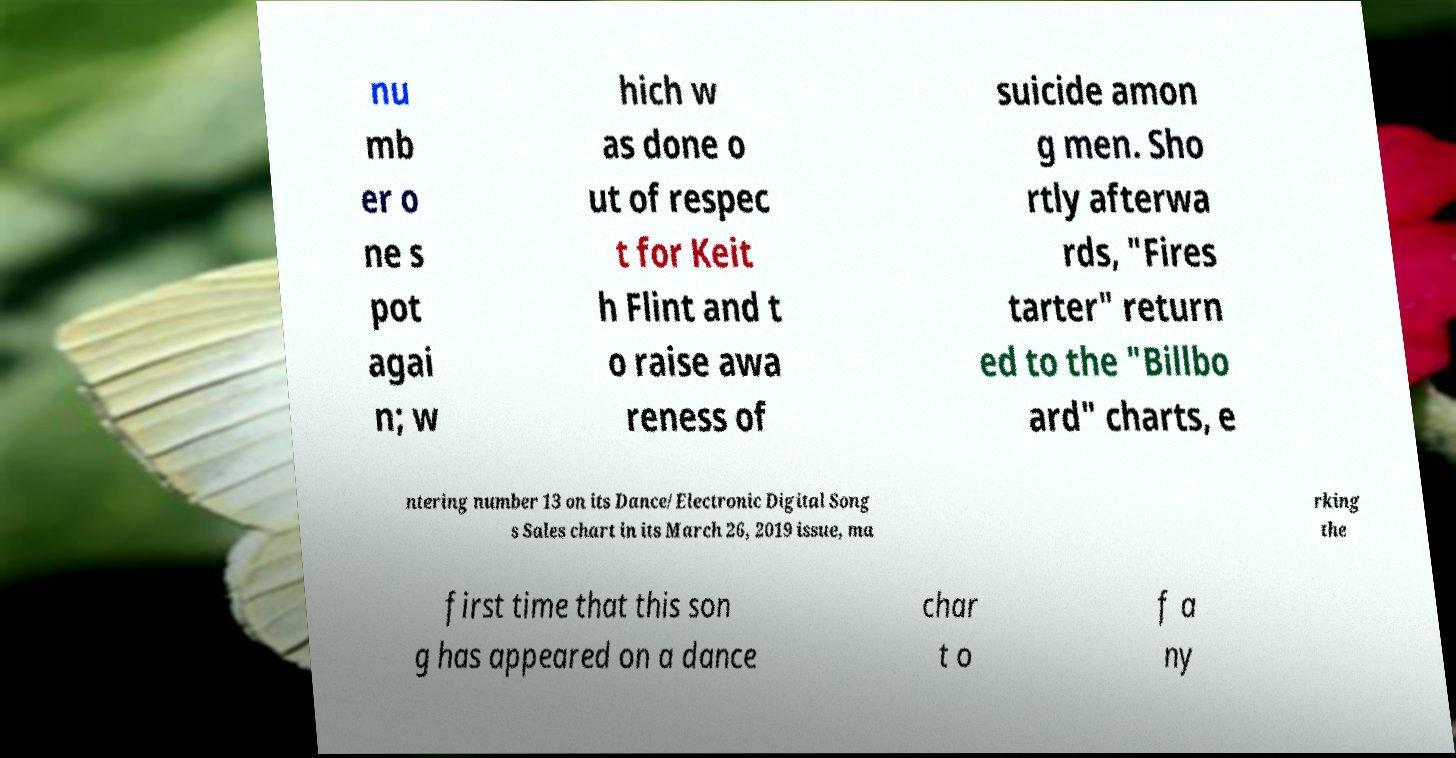Please identify and transcribe the text found in this image. nu mb er o ne s pot agai n; w hich w as done o ut of respec t for Keit h Flint and t o raise awa reness of suicide amon g men. Sho rtly afterwa rds, "Fires tarter" return ed to the "Billbo ard" charts, e ntering number 13 on its Dance/Electronic Digital Song s Sales chart in its March 26, 2019 issue, ma rking the first time that this son g has appeared on a dance char t o f a ny 